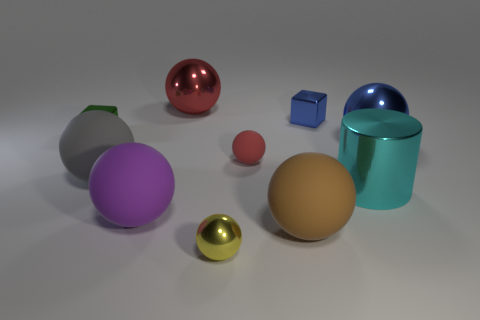What is the shape of the tiny red thing that is the same material as the purple object?
Provide a succinct answer. Sphere. Is there anything else that is the same shape as the cyan shiny thing?
Keep it short and to the point. No. The big blue thing is what shape?
Offer a very short reply. Sphere. There is a tiny shiny thing in front of the brown sphere; is its shape the same as the cyan metal thing?
Offer a very short reply. No. Is the number of small red spheres that are in front of the tiny red rubber sphere greater than the number of yellow metallic balls left of the large red metallic sphere?
Provide a short and direct response. No. How many other objects are the same size as the brown matte object?
Make the answer very short. 5. Do the yellow thing and the large metal thing behind the tiny green shiny block have the same shape?
Your response must be concise. Yes. How many matte objects are small green objects or cyan spheres?
Offer a very short reply. 0. Are there any large metal spheres that have the same color as the tiny rubber sphere?
Make the answer very short. Yes. Is there a green metallic block?
Provide a short and direct response. Yes. 